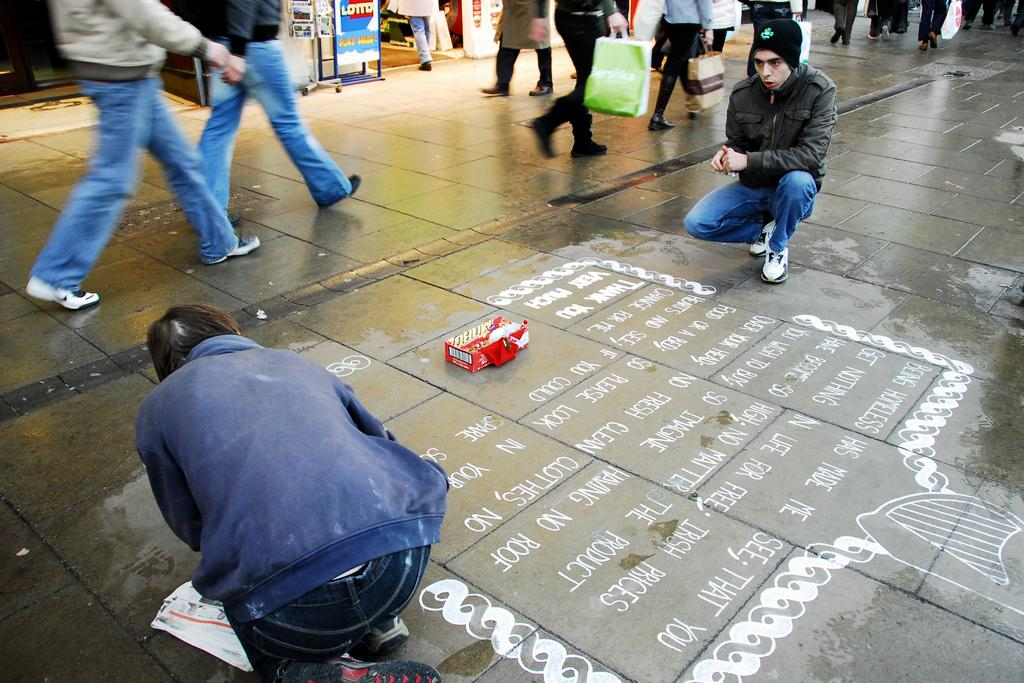What are the people in the image doing? There are many people walking on the road in the image. Is there anyone in the image who is not walking? Yes, there is a person drawing on the road. What can be inferred about the person drawing's attire? The person drawing is wearing a blue color jacket. What type of pets can be seen playing with a marble in the image? There are no pets or marbles present in the image; it features people walking and a person drawing on the road. 